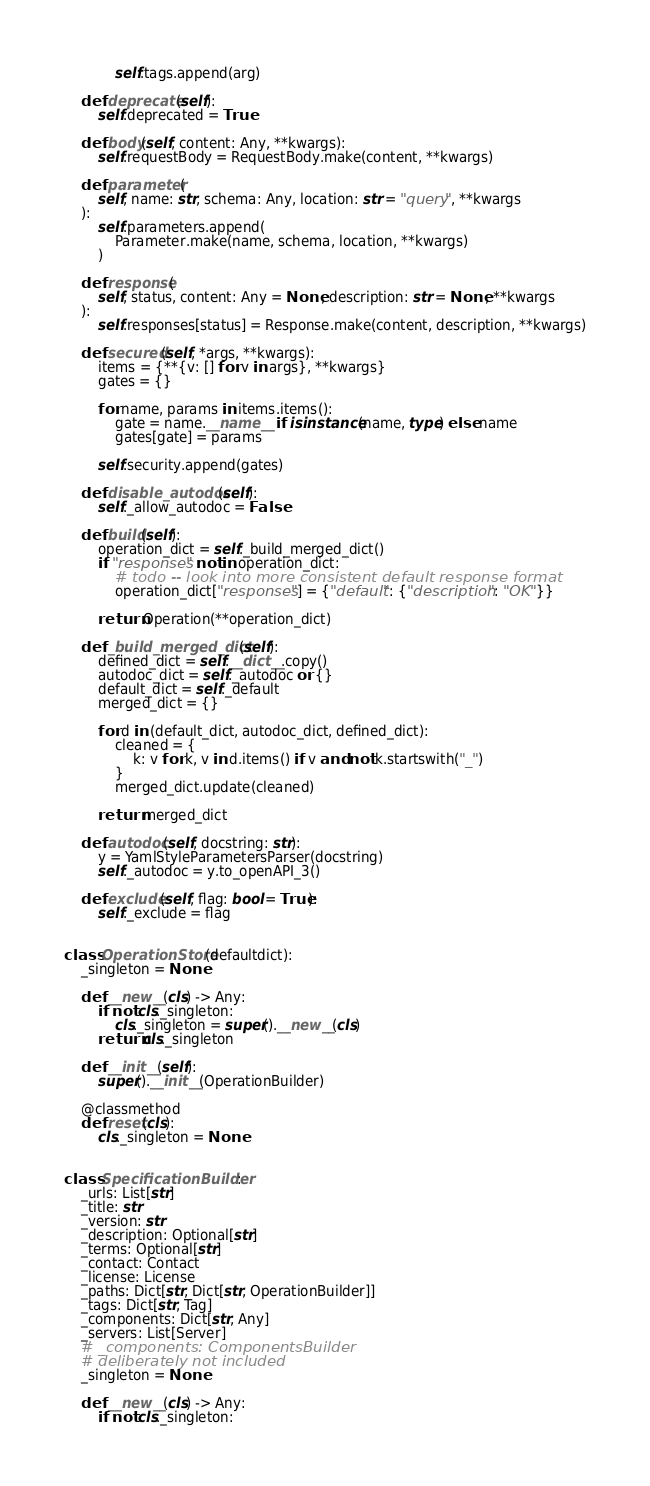<code> <loc_0><loc_0><loc_500><loc_500><_Python_>            self.tags.append(arg)

    def deprecate(self):
        self.deprecated = True

    def body(self, content: Any, **kwargs):
        self.requestBody = RequestBody.make(content, **kwargs)

    def parameter(
        self, name: str, schema: Any, location: str = "query", **kwargs
    ):
        self.parameters.append(
            Parameter.make(name, schema, location, **kwargs)
        )

    def response(
        self, status, content: Any = None, description: str = None, **kwargs
    ):
        self.responses[status] = Response.make(content, description, **kwargs)

    def secured(self, *args, **kwargs):
        items = {**{v: [] for v in args}, **kwargs}
        gates = {}

        for name, params in items.items():
            gate = name.__name__ if isinstance(name, type) else name
            gates[gate] = params

        self.security.append(gates)

    def disable_autodoc(self):
        self._allow_autodoc = False

    def build(self):
        operation_dict = self._build_merged_dict()
        if "responses" not in operation_dict:
            # todo -- look into more consistent default response format
            operation_dict["responses"] = {"default": {"description": "OK"}}

        return Operation(**operation_dict)

    def _build_merged_dict(self):
        defined_dict = self.__dict__.copy()
        autodoc_dict = self._autodoc or {}
        default_dict = self._default
        merged_dict = {}

        for d in (default_dict, autodoc_dict, defined_dict):
            cleaned = {
                k: v for k, v in d.items() if v and not k.startswith("_")
            }
            merged_dict.update(cleaned)

        return merged_dict

    def autodoc(self, docstring: str):
        y = YamlStyleParametersParser(docstring)
        self._autodoc = y.to_openAPI_3()

    def exclude(self, flag: bool = True):
        self._exclude = flag


class OperationStore(defaultdict):
    _singleton = None

    def __new__(cls) -> Any:
        if not cls._singleton:
            cls._singleton = super().__new__(cls)
        return cls._singleton

    def __init__(self):
        super().__init__(OperationBuilder)

    @classmethod
    def reset(cls):
        cls._singleton = None


class SpecificationBuilder:
    _urls: List[str]
    _title: str
    _version: str
    _description: Optional[str]
    _terms: Optional[str]
    _contact: Contact
    _license: License
    _paths: Dict[str, Dict[str, OperationBuilder]]
    _tags: Dict[str, Tag]
    _components: Dict[str, Any]
    _servers: List[Server]
    # _components: ComponentsBuilder
    # deliberately not included
    _singleton = None

    def __new__(cls) -> Any:
        if not cls._singleton:</code> 